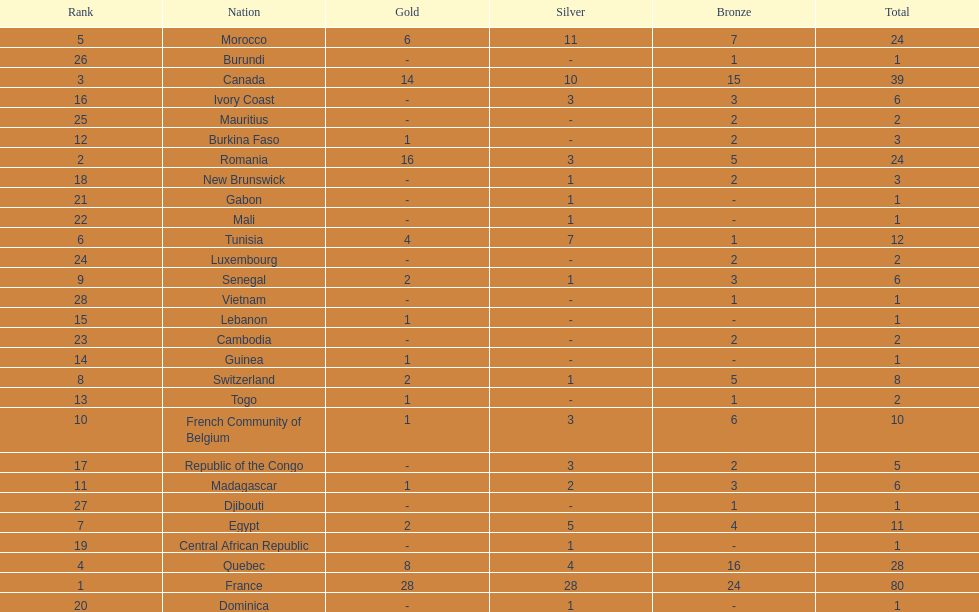How many nations won at least 10 medals? 8. 